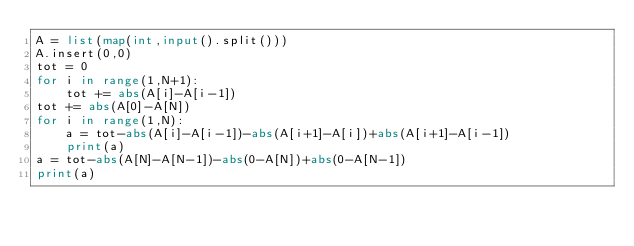Convert code to text. <code><loc_0><loc_0><loc_500><loc_500><_Python_>A = list(map(int,input().split()))
A.insert(0,0)
tot = 0
for i in range(1,N+1):
    tot += abs(A[i]-A[i-1])
tot += abs(A[0]-A[N])
for i in range(1,N):
    a = tot-abs(A[i]-A[i-1])-abs(A[i+1]-A[i])+abs(A[i+1]-A[i-1])
    print(a)
a = tot-abs(A[N]-A[N-1])-abs(0-A[N])+abs(0-A[N-1])
print(a)</code> 